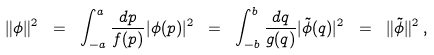<formula> <loc_0><loc_0><loc_500><loc_500>\| \phi \| ^ { 2 } \ = \ \int _ { - a } ^ { a } \frac { d p } { f ( p ) } | \phi ( p ) | ^ { 2 } \ = \ \int _ { - b } ^ { b } \frac { d q } { g ( q ) } | \tilde { \phi } ( q ) | ^ { 2 } \ = \ \| \tilde { \phi } \| ^ { 2 } \, ,</formula> 